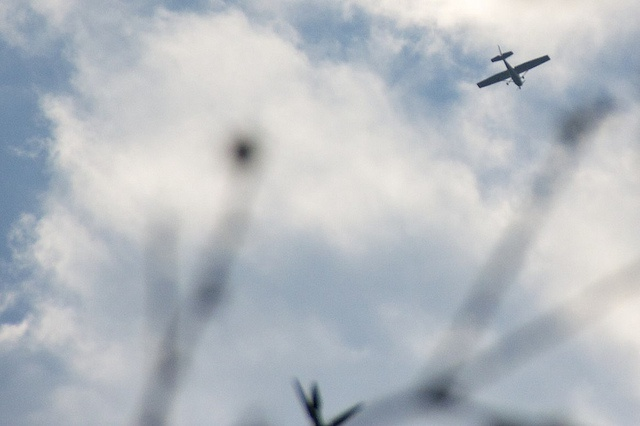Describe the objects in this image and their specific colors. I can see a airplane in darkgray, darkblue, navy, and gray tones in this image. 